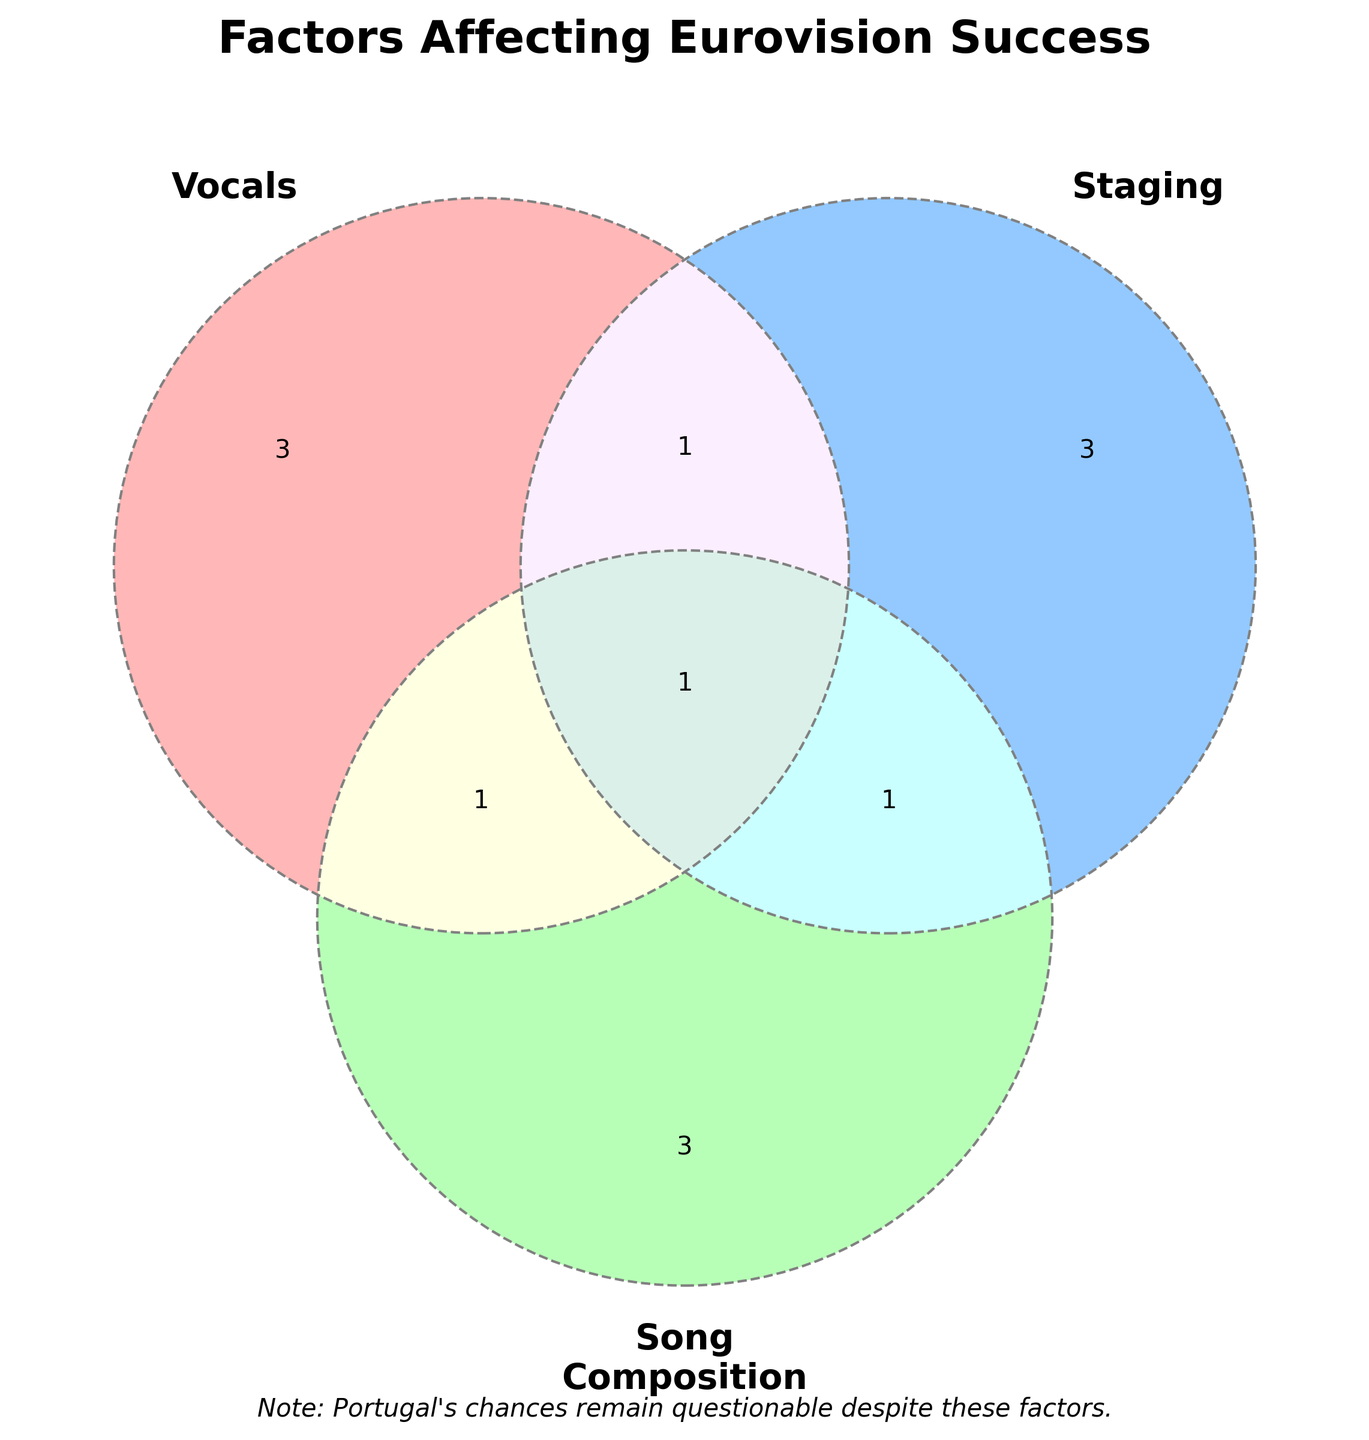What is the title of the figure? The title is displayed at the top of the figure and is meant to inform the viewer about the purpose of the Venn Diagram, indicating it covers factors that affect Eurovision success.
Answer: Factors Affecting Eurovision Success Which segment represents Loreen's "Euphoria"? Loreen's "Euphoria" falls into the intersection where all three circles meet, which means it combines elements of vocals, staging, and song composition.
Answer: Intersection of all three circles How many items belong exclusively to the staging category? By looking at the segment of the Venn Diagram that represents only the staging circle without overlapping with the other circles, we can count three items: Pyrotechnics, Innovative choreography, and LED backdrops.
Answer: 3 items Which factors are shared between vocals and song composition but not staging? These are items in the overlapping section between vocals and song composition circles that do not overlap with the staging circle. The segment includes only Fado-inspired ballads.
Answer: Fado-inspired ballads What are the common factors between vocals and staging? To find the answer, we look at the overlapping segment between the vocals and staging circles. The only item listed there is Salvador Sobral's simplicity.
Answer: Salvador Sobral's simplicity Which Eurovision factor is represented in all three categories? The diagram shows that the factor found in all three overlapping segments of vocals, staging, and song composition is Loreen's "Euphoria".
Answer: Loreen's "Euphoria" Are there more unique factors in vocals or song composition? We count the non-overlapping items in the vocals (3 items) and song composition (3 items). Both categories have an equal number of unique factors.
Answer: Equal (3 each) What do ABBA's "Waterloo" and Loreen's "Euphoria" share in common according to the Venn Diagram? ABBA's "Waterloo" and Loreen's "Euphoria" both involve song composition and staging. However, Loreen's "Euphoria" additionally includes vocals, as it falls into the intersection of all three categories.
Answer: Song composition and staging Which category has an equal number of non-overlapping items as the combination of vocals and song composition? The number of unique items for staging (3) and the combination of vocals and song composition (1) both equal 3 when added.
Answer: Staging Is there any item that pertains to both the staging and song composition categories but not to vocals? The Venn Diagram shows that ABBA's "Waterloo" belongs to both the staging and song composition categories without overlapping with vocals.
Answer: ABBA's "Waterloo" 